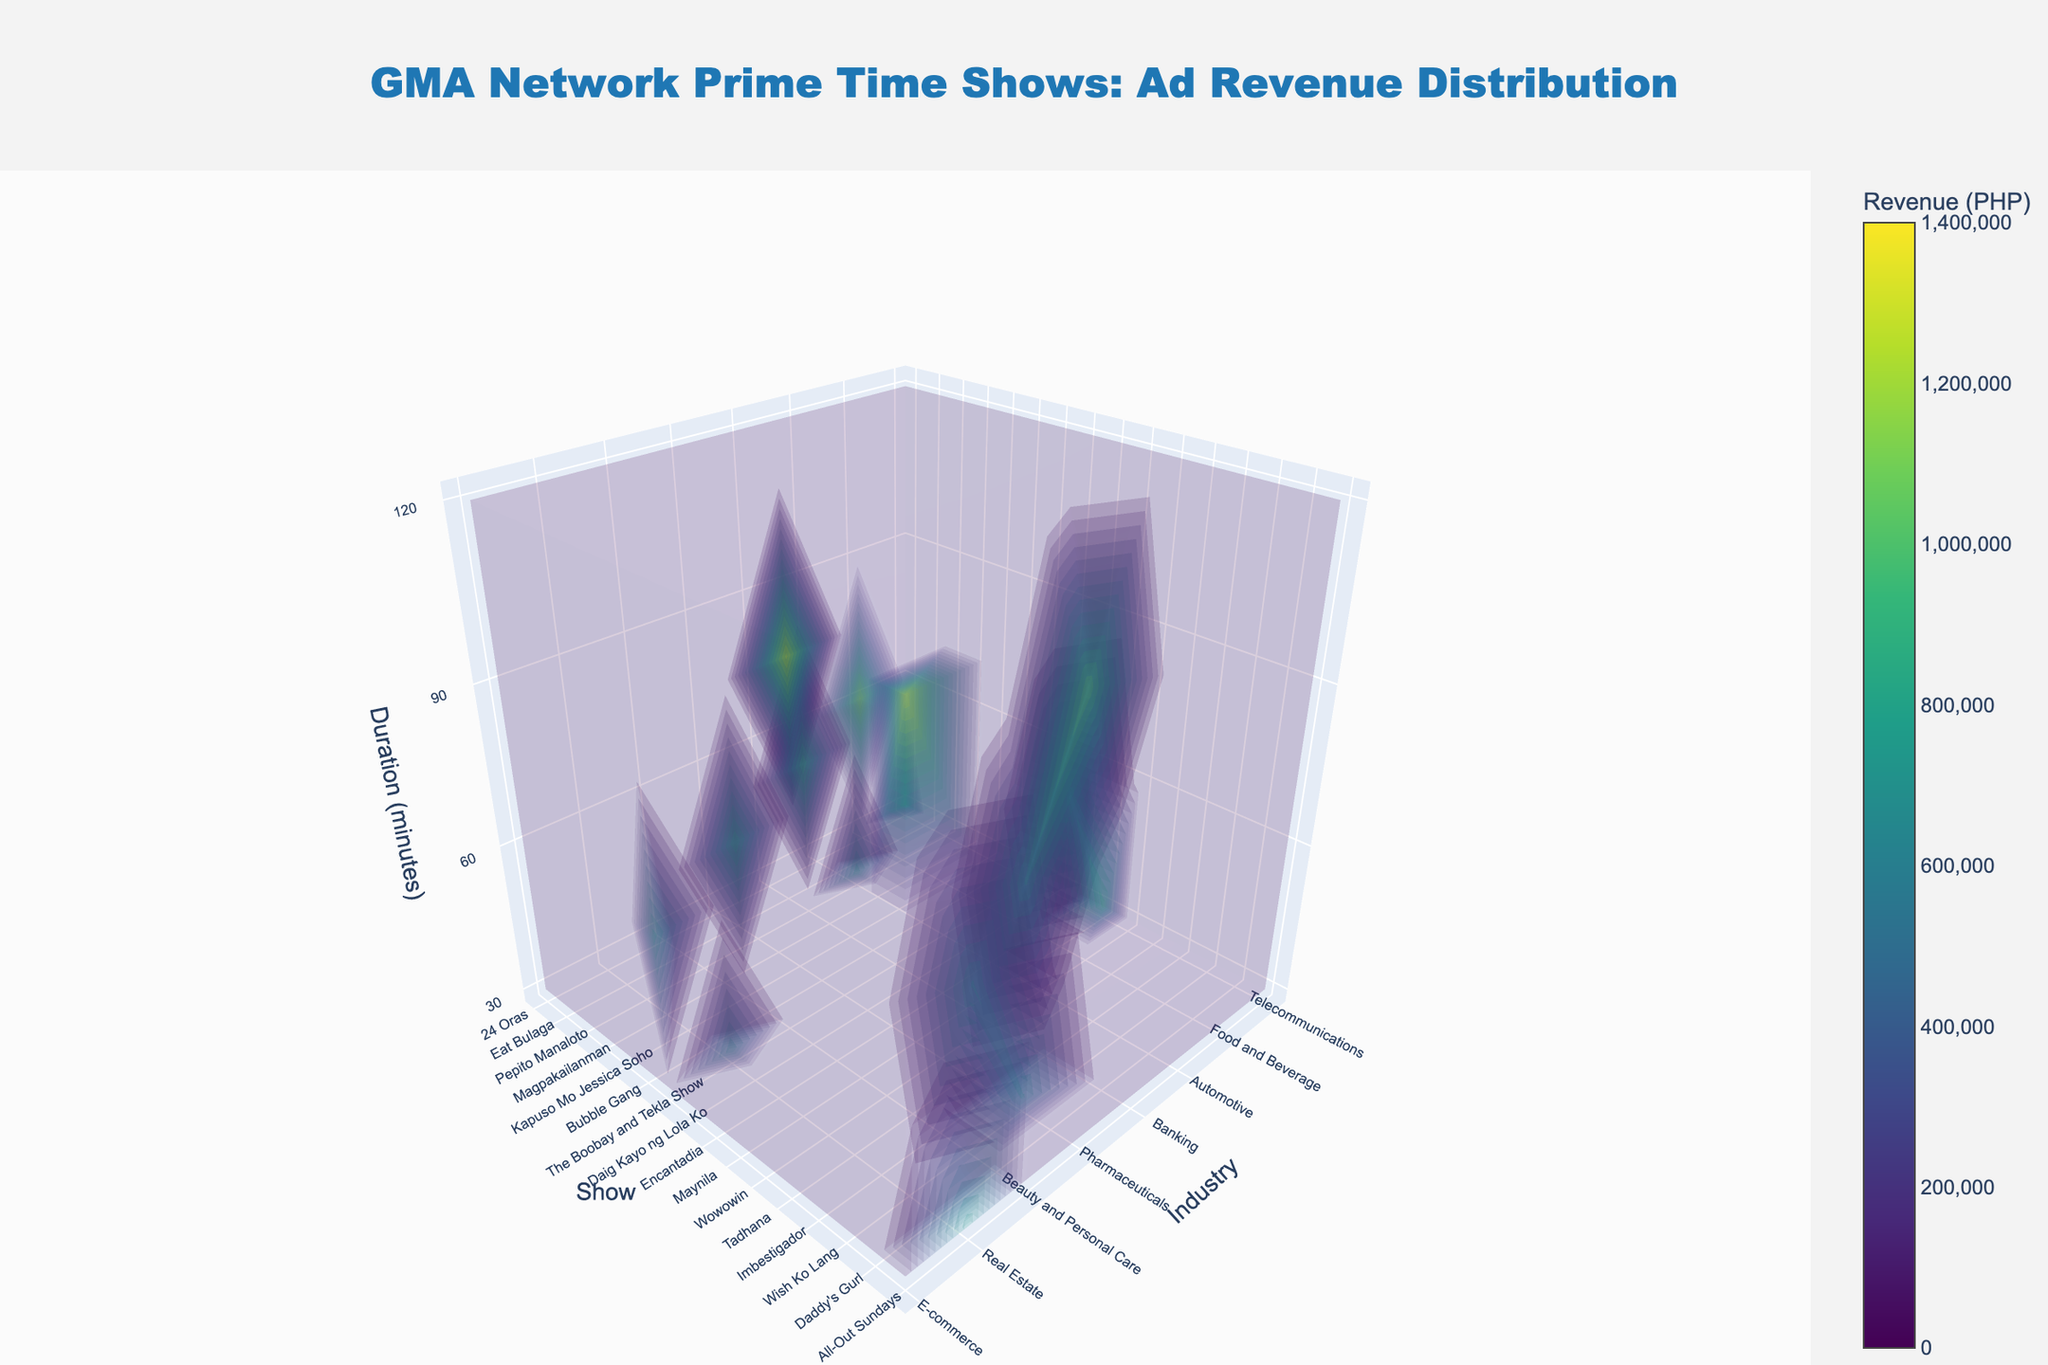What is the title of the plot? The title is prominently displayed at the top of the figure. It states the main subject of the 3D volume plot, which includes the network and the focus on ad revenue distribution.
Answer: GMA Network Prime Time Shows: Ad Revenue Distribution Which industry has the highest ad revenue for the show ‘Kapuso Mo Jessica Soho’? Locate the "Kapuso Mo Jessica Soho" on the show axis, then find the corresponding industry with the highest value on the third axis indicating revenue.
Answer: Automotive What are the two shows from the Telecommunications industry, and how do their revenues compare? First, identify the shows under the Telecommunications industry. Then, compare their revenue values represented in the 3D plot.
Answer: 24 Oras: 850,000 PHP and Eat Bulaga: 1,200,000 PHP. Eat Bulaga has higher revenue Which show with a duration of 90 minutes has the highest ad revenue? Look along the duration axis for the 90-minute mark. Then identify the show and its revenue.
Answer: All-Out Sundays What is the sum of ad revenue for all shows from the Food and Beverage industry? Locate the Food and Beverage industry in the plot and sum the revenues for all shows within this category.
Answer: Pepito Manaloto: 720,000 PHP and Magpakailanman: 950,000 PHP. The sum is 1,670,000 PHP Considering the duration of 60 minutes, which show has the lowest ad revenue, and what is it? Focus on the z-axis for the duration of 60 minutes, then identify the show with the lowest value in terms of ad revenue.
Answer: Maynila: 700,000 PHP If you compare the ad revenues of Banking and Pharmaceuticals industries for 30-minute slots, which industry has higher overall revenue? Extract the revenues of 30-minute slots for both industries and sum them up respectively. Banking: The Boobay and Tekla Show - 650,000 PHP, Pharmaceuticals: Encantadia - 920,000 PHP.
Answer: Pharmaceuticals What is the color used to denote higher ad revenue in the plot? Analyze the color scale in the plot which indicates the value progression. Higher values typically correspond to a certain range of colors on the scale.
Answer: Dark colors Which show in the Real Estate industry has higher revenue: Imbestigador or Wish Ko Lang, and by how much? Compare the revenues for both shows under the Real Estate industry sector seen along the y-axis.
Answer: Wish Ko Lang by 70,000 PHP 